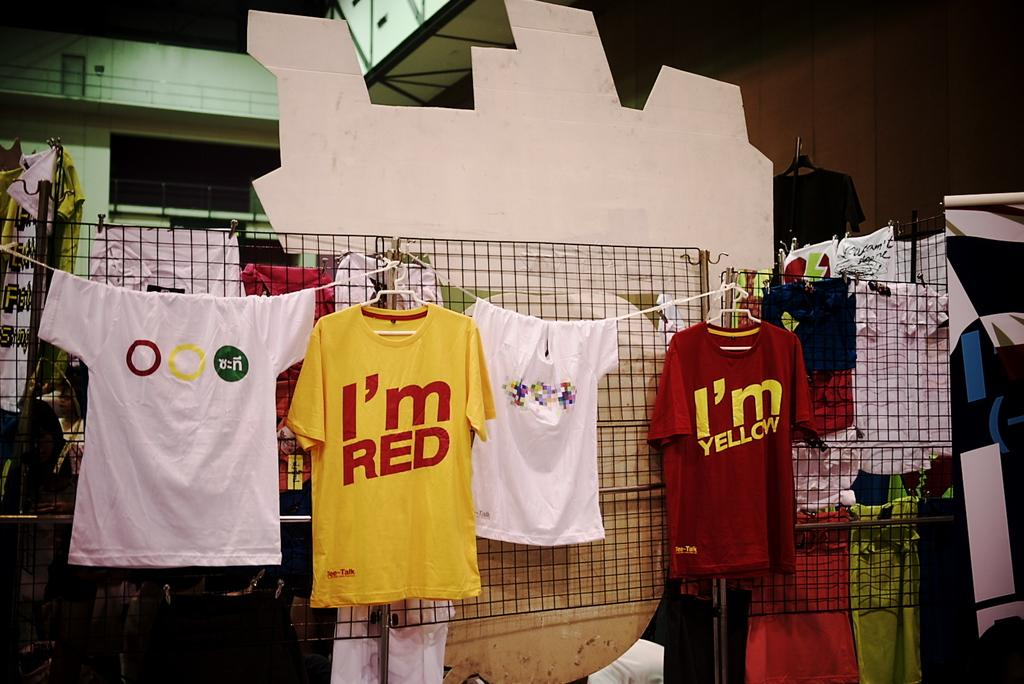Provide a one-sentence caption for the provided image. "I'm Red" and "I'm Yellow" T-Shirts displayed on a clothesline. 